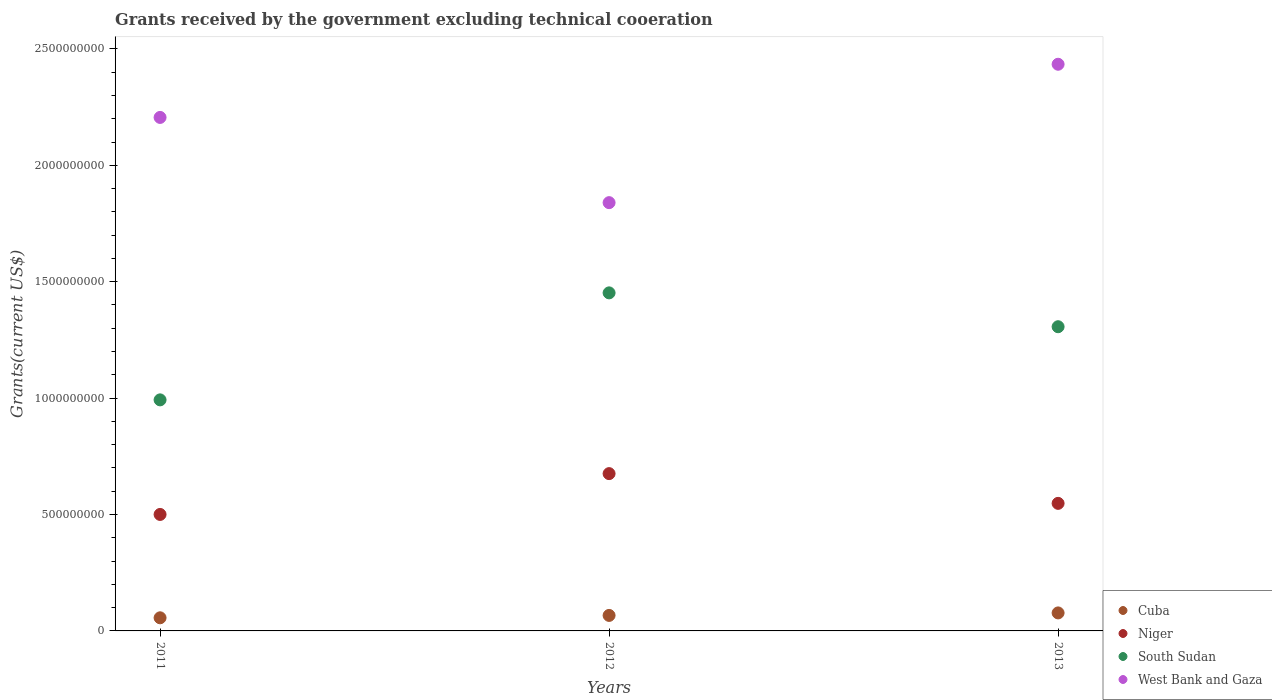Is the number of dotlines equal to the number of legend labels?
Your response must be concise. Yes. What is the total grants received by the government in South Sudan in 2012?
Offer a terse response. 1.45e+09. Across all years, what is the maximum total grants received by the government in Niger?
Make the answer very short. 6.76e+08. Across all years, what is the minimum total grants received by the government in Niger?
Your answer should be very brief. 5.00e+08. In which year was the total grants received by the government in South Sudan minimum?
Provide a succinct answer. 2011. What is the total total grants received by the government in South Sudan in the graph?
Ensure brevity in your answer.  3.75e+09. What is the difference between the total grants received by the government in South Sudan in 2011 and that in 2013?
Your answer should be compact. -3.14e+08. What is the difference between the total grants received by the government in Cuba in 2011 and the total grants received by the government in West Bank and Gaza in 2013?
Offer a very short reply. -2.38e+09. What is the average total grants received by the government in Cuba per year?
Offer a terse response. 6.68e+07. In the year 2011, what is the difference between the total grants received by the government in South Sudan and total grants received by the government in Cuba?
Your answer should be compact. 9.36e+08. In how many years, is the total grants received by the government in South Sudan greater than 300000000 US$?
Keep it short and to the point. 3. What is the ratio of the total grants received by the government in Cuba in 2011 to that in 2012?
Make the answer very short. 0.85. Is the total grants received by the government in Cuba in 2011 less than that in 2012?
Provide a succinct answer. Yes. Is the difference between the total grants received by the government in South Sudan in 2011 and 2013 greater than the difference between the total grants received by the government in Cuba in 2011 and 2013?
Offer a very short reply. No. What is the difference between the highest and the second highest total grants received by the government in South Sudan?
Your answer should be compact. 1.45e+08. What is the difference between the highest and the lowest total grants received by the government in Cuba?
Make the answer very short. 2.10e+07. In how many years, is the total grants received by the government in Niger greater than the average total grants received by the government in Niger taken over all years?
Offer a very short reply. 1. Is it the case that in every year, the sum of the total grants received by the government in Cuba and total grants received by the government in Niger  is greater than the sum of total grants received by the government in West Bank and Gaza and total grants received by the government in South Sudan?
Your response must be concise. Yes. Is it the case that in every year, the sum of the total grants received by the government in West Bank and Gaza and total grants received by the government in Cuba  is greater than the total grants received by the government in South Sudan?
Make the answer very short. Yes. Does the total grants received by the government in Niger monotonically increase over the years?
Your response must be concise. No. Is the total grants received by the government in Niger strictly greater than the total grants received by the government in Cuba over the years?
Make the answer very short. Yes. Is the total grants received by the government in West Bank and Gaza strictly less than the total grants received by the government in Cuba over the years?
Provide a succinct answer. No. How many years are there in the graph?
Your response must be concise. 3. What is the difference between two consecutive major ticks on the Y-axis?
Provide a succinct answer. 5.00e+08. Are the values on the major ticks of Y-axis written in scientific E-notation?
Ensure brevity in your answer.  No. Does the graph contain grids?
Keep it short and to the point. No. How many legend labels are there?
Your answer should be very brief. 4. How are the legend labels stacked?
Your answer should be compact. Vertical. What is the title of the graph?
Offer a very short reply. Grants received by the government excluding technical cooeration. Does "Algeria" appear as one of the legend labels in the graph?
Your response must be concise. No. What is the label or title of the X-axis?
Your response must be concise. Years. What is the label or title of the Y-axis?
Your answer should be very brief. Grants(current US$). What is the Grants(current US$) of Cuba in 2011?
Provide a short and direct response. 5.64e+07. What is the Grants(current US$) in Niger in 2011?
Provide a short and direct response. 5.00e+08. What is the Grants(current US$) in South Sudan in 2011?
Offer a terse response. 9.92e+08. What is the Grants(current US$) in West Bank and Gaza in 2011?
Your response must be concise. 2.21e+09. What is the Grants(current US$) of Cuba in 2012?
Your response must be concise. 6.66e+07. What is the Grants(current US$) in Niger in 2012?
Your answer should be compact. 6.76e+08. What is the Grants(current US$) in South Sudan in 2012?
Give a very brief answer. 1.45e+09. What is the Grants(current US$) in West Bank and Gaza in 2012?
Ensure brevity in your answer.  1.84e+09. What is the Grants(current US$) of Cuba in 2013?
Provide a succinct answer. 7.73e+07. What is the Grants(current US$) in Niger in 2013?
Keep it short and to the point. 5.48e+08. What is the Grants(current US$) in South Sudan in 2013?
Your answer should be very brief. 1.31e+09. What is the Grants(current US$) in West Bank and Gaza in 2013?
Provide a short and direct response. 2.43e+09. Across all years, what is the maximum Grants(current US$) in Cuba?
Your answer should be compact. 7.73e+07. Across all years, what is the maximum Grants(current US$) in Niger?
Your answer should be very brief. 6.76e+08. Across all years, what is the maximum Grants(current US$) in South Sudan?
Keep it short and to the point. 1.45e+09. Across all years, what is the maximum Grants(current US$) in West Bank and Gaza?
Your response must be concise. 2.43e+09. Across all years, what is the minimum Grants(current US$) in Cuba?
Provide a succinct answer. 5.64e+07. Across all years, what is the minimum Grants(current US$) in Niger?
Keep it short and to the point. 5.00e+08. Across all years, what is the minimum Grants(current US$) of South Sudan?
Your response must be concise. 9.92e+08. Across all years, what is the minimum Grants(current US$) in West Bank and Gaza?
Offer a terse response. 1.84e+09. What is the total Grants(current US$) of Cuba in the graph?
Offer a very short reply. 2.00e+08. What is the total Grants(current US$) of Niger in the graph?
Your answer should be very brief. 1.72e+09. What is the total Grants(current US$) of South Sudan in the graph?
Your response must be concise. 3.75e+09. What is the total Grants(current US$) of West Bank and Gaza in the graph?
Provide a short and direct response. 6.48e+09. What is the difference between the Grants(current US$) in Cuba in 2011 and that in 2012?
Offer a terse response. -1.02e+07. What is the difference between the Grants(current US$) in Niger in 2011 and that in 2012?
Your answer should be very brief. -1.75e+08. What is the difference between the Grants(current US$) in South Sudan in 2011 and that in 2012?
Give a very brief answer. -4.60e+08. What is the difference between the Grants(current US$) of West Bank and Gaza in 2011 and that in 2012?
Offer a terse response. 3.66e+08. What is the difference between the Grants(current US$) of Cuba in 2011 and that in 2013?
Offer a very short reply. -2.10e+07. What is the difference between the Grants(current US$) of Niger in 2011 and that in 2013?
Give a very brief answer. -4.76e+07. What is the difference between the Grants(current US$) of South Sudan in 2011 and that in 2013?
Ensure brevity in your answer.  -3.14e+08. What is the difference between the Grants(current US$) in West Bank and Gaza in 2011 and that in 2013?
Offer a very short reply. -2.28e+08. What is the difference between the Grants(current US$) in Cuba in 2012 and that in 2013?
Provide a short and direct response. -1.08e+07. What is the difference between the Grants(current US$) in Niger in 2012 and that in 2013?
Provide a short and direct response. 1.28e+08. What is the difference between the Grants(current US$) in South Sudan in 2012 and that in 2013?
Your response must be concise. 1.45e+08. What is the difference between the Grants(current US$) of West Bank and Gaza in 2012 and that in 2013?
Give a very brief answer. -5.94e+08. What is the difference between the Grants(current US$) of Cuba in 2011 and the Grants(current US$) of Niger in 2012?
Make the answer very short. -6.19e+08. What is the difference between the Grants(current US$) in Cuba in 2011 and the Grants(current US$) in South Sudan in 2012?
Provide a short and direct response. -1.40e+09. What is the difference between the Grants(current US$) of Cuba in 2011 and the Grants(current US$) of West Bank and Gaza in 2012?
Offer a terse response. -1.78e+09. What is the difference between the Grants(current US$) of Niger in 2011 and the Grants(current US$) of South Sudan in 2012?
Offer a very short reply. -9.52e+08. What is the difference between the Grants(current US$) of Niger in 2011 and the Grants(current US$) of West Bank and Gaza in 2012?
Your answer should be compact. -1.34e+09. What is the difference between the Grants(current US$) of South Sudan in 2011 and the Grants(current US$) of West Bank and Gaza in 2012?
Ensure brevity in your answer.  -8.47e+08. What is the difference between the Grants(current US$) in Cuba in 2011 and the Grants(current US$) in Niger in 2013?
Provide a succinct answer. -4.92e+08. What is the difference between the Grants(current US$) in Cuba in 2011 and the Grants(current US$) in South Sudan in 2013?
Provide a short and direct response. -1.25e+09. What is the difference between the Grants(current US$) of Cuba in 2011 and the Grants(current US$) of West Bank and Gaza in 2013?
Provide a short and direct response. -2.38e+09. What is the difference between the Grants(current US$) of Niger in 2011 and the Grants(current US$) of South Sudan in 2013?
Give a very brief answer. -8.06e+08. What is the difference between the Grants(current US$) of Niger in 2011 and the Grants(current US$) of West Bank and Gaza in 2013?
Give a very brief answer. -1.93e+09. What is the difference between the Grants(current US$) of South Sudan in 2011 and the Grants(current US$) of West Bank and Gaza in 2013?
Provide a succinct answer. -1.44e+09. What is the difference between the Grants(current US$) of Cuba in 2012 and the Grants(current US$) of Niger in 2013?
Provide a succinct answer. -4.81e+08. What is the difference between the Grants(current US$) of Cuba in 2012 and the Grants(current US$) of South Sudan in 2013?
Your answer should be compact. -1.24e+09. What is the difference between the Grants(current US$) in Cuba in 2012 and the Grants(current US$) in West Bank and Gaza in 2013?
Provide a succinct answer. -2.37e+09. What is the difference between the Grants(current US$) in Niger in 2012 and the Grants(current US$) in South Sudan in 2013?
Your response must be concise. -6.31e+08. What is the difference between the Grants(current US$) in Niger in 2012 and the Grants(current US$) in West Bank and Gaza in 2013?
Your answer should be compact. -1.76e+09. What is the difference between the Grants(current US$) of South Sudan in 2012 and the Grants(current US$) of West Bank and Gaza in 2013?
Offer a very short reply. -9.82e+08. What is the average Grants(current US$) in Cuba per year?
Your answer should be very brief. 6.68e+07. What is the average Grants(current US$) of Niger per year?
Offer a very short reply. 5.75e+08. What is the average Grants(current US$) in South Sudan per year?
Your answer should be compact. 1.25e+09. What is the average Grants(current US$) in West Bank and Gaza per year?
Your response must be concise. 2.16e+09. In the year 2011, what is the difference between the Grants(current US$) in Cuba and Grants(current US$) in Niger?
Give a very brief answer. -4.44e+08. In the year 2011, what is the difference between the Grants(current US$) of Cuba and Grants(current US$) of South Sudan?
Your answer should be compact. -9.36e+08. In the year 2011, what is the difference between the Grants(current US$) of Cuba and Grants(current US$) of West Bank and Gaza?
Your answer should be very brief. -2.15e+09. In the year 2011, what is the difference between the Grants(current US$) in Niger and Grants(current US$) in South Sudan?
Ensure brevity in your answer.  -4.92e+08. In the year 2011, what is the difference between the Grants(current US$) of Niger and Grants(current US$) of West Bank and Gaza?
Keep it short and to the point. -1.71e+09. In the year 2011, what is the difference between the Grants(current US$) in South Sudan and Grants(current US$) in West Bank and Gaza?
Your answer should be compact. -1.21e+09. In the year 2012, what is the difference between the Grants(current US$) of Cuba and Grants(current US$) of Niger?
Your answer should be very brief. -6.09e+08. In the year 2012, what is the difference between the Grants(current US$) of Cuba and Grants(current US$) of South Sudan?
Your answer should be compact. -1.39e+09. In the year 2012, what is the difference between the Grants(current US$) of Cuba and Grants(current US$) of West Bank and Gaza?
Ensure brevity in your answer.  -1.77e+09. In the year 2012, what is the difference between the Grants(current US$) of Niger and Grants(current US$) of South Sudan?
Offer a terse response. -7.76e+08. In the year 2012, what is the difference between the Grants(current US$) in Niger and Grants(current US$) in West Bank and Gaza?
Provide a succinct answer. -1.16e+09. In the year 2012, what is the difference between the Grants(current US$) in South Sudan and Grants(current US$) in West Bank and Gaza?
Provide a short and direct response. -3.88e+08. In the year 2013, what is the difference between the Grants(current US$) of Cuba and Grants(current US$) of Niger?
Your response must be concise. -4.71e+08. In the year 2013, what is the difference between the Grants(current US$) of Cuba and Grants(current US$) of South Sudan?
Provide a succinct answer. -1.23e+09. In the year 2013, what is the difference between the Grants(current US$) in Cuba and Grants(current US$) in West Bank and Gaza?
Your response must be concise. -2.36e+09. In the year 2013, what is the difference between the Grants(current US$) in Niger and Grants(current US$) in South Sudan?
Your answer should be very brief. -7.59e+08. In the year 2013, what is the difference between the Grants(current US$) of Niger and Grants(current US$) of West Bank and Gaza?
Your response must be concise. -1.89e+09. In the year 2013, what is the difference between the Grants(current US$) of South Sudan and Grants(current US$) of West Bank and Gaza?
Offer a terse response. -1.13e+09. What is the ratio of the Grants(current US$) in Cuba in 2011 to that in 2012?
Your answer should be compact. 0.85. What is the ratio of the Grants(current US$) of Niger in 2011 to that in 2012?
Your answer should be very brief. 0.74. What is the ratio of the Grants(current US$) in South Sudan in 2011 to that in 2012?
Provide a short and direct response. 0.68. What is the ratio of the Grants(current US$) in West Bank and Gaza in 2011 to that in 2012?
Keep it short and to the point. 1.2. What is the ratio of the Grants(current US$) in Cuba in 2011 to that in 2013?
Your response must be concise. 0.73. What is the ratio of the Grants(current US$) of Niger in 2011 to that in 2013?
Ensure brevity in your answer.  0.91. What is the ratio of the Grants(current US$) of South Sudan in 2011 to that in 2013?
Provide a short and direct response. 0.76. What is the ratio of the Grants(current US$) of West Bank and Gaza in 2011 to that in 2013?
Offer a very short reply. 0.91. What is the ratio of the Grants(current US$) in Cuba in 2012 to that in 2013?
Provide a succinct answer. 0.86. What is the ratio of the Grants(current US$) of Niger in 2012 to that in 2013?
Give a very brief answer. 1.23. What is the ratio of the Grants(current US$) in South Sudan in 2012 to that in 2013?
Keep it short and to the point. 1.11. What is the ratio of the Grants(current US$) of West Bank and Gaza in 2012 to that in 2013?
Your answer should be compact. 0.76. What is the difference between the highest and the second highest Grants(current US$) of Cuba?
Keep it short and to the point. 1.08e+07. What is the difference between the highest and the second highest Grants(current US$) in Niger?
Your answer should be very brief. 1.28e+08. What is the difference between the highest and the second highest Grants(current US$) of South Sudan?
Your answer should be compact. 1.45e+08. What is the difference between the highest and the second highest Grants(current US$) of West Bank and Gaza?
Offer a very short reply. 2.28e+08. What is the difference between the highest and the lowest Grants(current US$) of Cuba?
Offer a terse response. 2.10e+07. What is the difference between the highest and the lowest Grants(current US$) in Niger?
Offer a terse response. 1.75e+08. What is the difference between the highest and the lowest Grants(current US$) of South Sudan?
Your answer should be compact. 4.60e+08. What is the difference between the highest and the lowest Grants(current US$) of West Bank and Gaza?
Ensure brevity in your answer.  5.94e+08. 